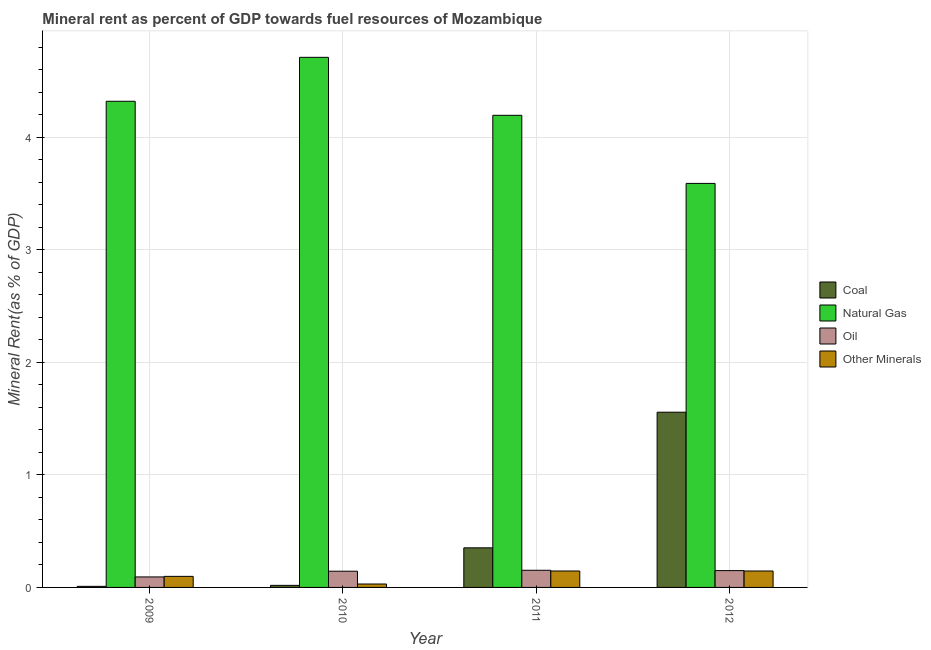Are the number of bars per tick equal to the number of legend labels?
Give a very brief answer. Yes. How many bars are there on the 4th tick from the left?
Ensure brevity in your answer.  4. What is the  rent of other minerals in 2012?
Your answer should be compact. 0.15. Across all years, what is the maximum coal rent?
Ensure brevity in your answer.  1.56. Across all years, what is the minimum coal rent?
Offer a very short reply. 0.01. What is the total coal rent in the graph?
Offer a terse response. 1.94. What is the difference between the coal rent in 2010 and that in 2012?
Offer a very short reply. -1.54. What is the difference between the natural gas rent in 2009 and the oil rent in 2011?
Make the answer very short. 0.12. What is the average oil rent per year?
Your answer should be very brief. 0.13. What is the ratio of the oil rent in 2010 to that in 2011?
Ensure brevity in your answer.  0.95. Is the natural gas rent in 2010 less than that in 2012?
Your answer should be compact. No. Is the difference between the  rent of other minerals in 2010 and 2011 greater than the difference between the natural gas rent in 2010 and 2011?
Provide a succinct answer. No. What is the difference between the highest and the second highest natural gas rent?
Offer a very short reply. 0.39. What is the difference between the highest and the lowest natural gas rent?
Your answer should be very brief. 1.12. In how many years, is the oil rent greater than the average oil rent taken over all years?
Your answer should be very brief. 3. Is it the case that in every year, the sum of the  rent of other minerals and coal rent is greater than the sum of oil rent and natural gas rent?
Give a very brief answer. No. What does the 2nd bar from the left in 2009 represents?
Your answer should be very brief. Natural Gas. What does the 2nd bar from the right in 2012 represents?
Your response must be concise. Oil. How many bars are there?
Your answer should be compact. 16. Are the values on the major ticks of Y-axis written in scientific E-notation?
Your answer should be compact. No. What is the title of the graph?
Ensure brevity in your answer.  Mineral rent as percent of GDP towards fuel resources of Mozambique. Does "Secondary vocational education" appear as one of the legend labels in the graph?
Your answer should be very brief. No. What is the label or title of the X-axis?
Your answer should be compact. Year. What is the label or title of the Y-axis?
Your answer should be very brief. Mineral Rent(as % of GDP). What is the Mineral Rent(as % of GDP) of Coal in 2009?
Provide a short and direct response. 0.01. What is the Mineral Rent(as % of GDP) of Natural Gas in 2009?
Give a very brief answer. 4.32. What is the Mineral Rent(as % of GDP) in Oil in 2009?
Provide a succinct answer. 0.09. What is the Mineral Rent(as % of GDP) in Other Minerals in 2009?
Offer a terse response. 0.1. What is the Mineral Rent(as % of GDP) in Coal in 2010?
Keep it short and to the point. 0.02. What is the Mineral Rent(as % of GDP) in Natural Gas in 2010?
Offer a very short reply. 4.71. What is the Mineral Rent(as % of GDP) of Oil in 2010?
Ensure brevity in your answer.  0.14. What is the Mineral Rent(as % of GDP) in Other Minerals in 2010?
Offer a terse response. 0.03. What is the Mineral Rent(as % of GDP) of Coal in 2011?
Your response must be concise. 0.35. What is the Mineral Rent(as % of GDP) of Natural Gas in 2011?
Make the answer very short. 4.2. What is the Mineral Rent(as % of GDP) in Oil in 2011?
Offer a very short reply. 0.15. What is the Mineral Rent(as % of GDP) in Other Minerals in 2011?
Give a very brief answer. 0.15. What is the Mineral Rent(as % of GDP) of Coal in 2012?
Provide a short and direct response. 1.56. What is the Mineral Rent(as % of GDP) of Natural Gas in 2012?
Provide a short and direct response. 3.59. What is the Mineral Rent(as % of GDP) of Oil in 2012?
Keep it short and to the point. 0.15. What is the Mineral Rent(as % of GDP) in Other Minerals in 2012?
Offer a very short reply. 0.15. Across all years, what is the maximum Mineral Rent(as % of GDP) in Coal?
Make the answer very short. 1.56. Across all years, what is the maximum Mineral Rent(as % of GDP) in Natural Gas?
Give a very brief answer. 4.71. Across all years, what is the maximum Mineral Rent(as % of GDP) in Oil?
Your answer should be compact. 0.15. Across all years, what is the maximum Mineral Rent(as % of GDP) in Other Minerals?
Offer a terse response. 0.15. Across all years, what is the minimum Mineral Rent(as % of GDP) in Coal?
Offer a terse response. 0.01. Across all years, what is the minimum Mineral Rent(as % of GDP) in Natural Gas?
Your answer should be very brief. 3.59. Across all years, what is the minimum Mineral Rent(as % of GDP) of Oil?
Offer a very short reply. 0.09. Across all years, what is the minimum Mineral Rent(as % of GDP) of Other Minerals?
Ensure brevity in your answer.  0.03. What is the total Mineral Rent(as % of GDP) in Coal in the graph?
Keep it short and to the point. 1.94. What is the total Mineral Rent(as % of GDP) in Natural Gas in the graph?
Your answer should be very brief. 16.82. What is the total Mineral Rent(as % of GDP) in Oil in the graph?
Your answer should be very brief. 0.54. What is the total Mineral Rent(as % of GDP) in Other Minerals in the graph?
Ensure brevity in your answer.  0.42. What is the difference between the Mineral Rent(as % of GDP) in Coal in 2009 and that in 2010?
Ensure brevity in your answer.  -0.01. What is the difference between the Mineral Rent(as % of GDP) of Natural Gas in 2009 and that in 2010?
Provide a short and direct response. -0.39. What is the difference between the Mineral Rent(as % of GDP) of Oil in 2009 and that in 2010?
Your answer should be compact. -0.05. What is the difference between the Mineral Rent(as % of GDP) in Other Minerals in 2009 and that in 2010?
Make the answer very short. 0.07. What is the difference between the Mineral Rent(as % of GDP) of Coal in 2009 and that in 2011?
Your response must be concise. -0.34. What is the difference between the Mineral Rent(as % of GDP) in Natural Gas in 2009 and that in 2011?
Ensure brevity in your answer.  0.12. What is the difference between the Mineral Rent(as % of GDP) in Oil in 2009 and that in 2011?
Your response must be concise. -0.06. What is the difference between the Mineral Rent(as % of GDP) in Other Minerals in 2009 and that in 2011?
Your answer should be compact. -0.05. What is the difference between the Mineral Rent(as % of GDP) in Coal in 2009 and that in 2012?
Your answer should be very brief. -1.55. What is the difference between the Mineral Rent(as % of GDP) of Natural Gas in 2009 and that in 2012?
Provide a succinct answer. 0.73. What is the difference between the Mineral Rent(as % of GDP) in Oil in 2009 and that in 2012?
Ensure brevity in your answer.  -0.06. What is the difference between the Mineral Rent(as % of GDP) in Other Minerals in 2009 and that in 2012?
Your answer should be compact. -0.05. What is the difference between the Mineral Rent(as % of GDP) of Coal in 2010 and that in 2011?
Provide a short and direct response. -0.33. What is the difference between the Mineral Rent(as % of GDP) of Natural Gas in 2010 and that in 2011?
Give a very brief answer. 0.52. What is the difference between the Mineral Rent(as % of GDP) of Oil in 2010 and that in 2011?
Your answer should be very brief. -0.01. What is the difference between the Mineral Rent(as % of GDP) in Other Minerals in 2010 and that in 2011?
Your response must be concise. -0.12. What is the difference between the Mineral Rent(as % of GDP) in Coal in 2010 and that in 2012?
Make the answer very short. -1.54. What is the difference between the Mineral Rent(as % of GDP) of Natural Gas in 2010 and that in 2012?
Your answer should be very brief. 1.12. What is the difference between the Mineral Rent(as % of GDP) of Oil in 2010 and that in 2012?
Give a very brief answer. -0.01. What is the difference between the Mineral Rent(as % of GDP) in Other Minerals in 2010 and that in 2012?
Keep it short and to the point. -0.12. What is the difference between the Mineral Rent(as % of GDP) of Coal in 2011 and that in 2012?
Make the answer very short. -1.21. What is the difference between the Mineral Rent(as % of GDP) in Natural Gas in 2011 and that in 2012?
Your answer should be very brief. 0.61. What is the difference between the Mineral Rent(as % of GDP) in Oil in 2011 and that in 2012?
Keep it short and to the point. 0. What is the difference between the Mineral Rent(as % of GDP) in Coal in 2009 and the Mineral Rent(as % of GDP) in Natural Gas in 2010?
Your answer should be compact. -4.7. What is the difference between the Mineral Rent(as % of GDP) in Coal in 2009 and the Mineral Rent(as % of GDP) in Oil in 2010?
Offer a terse response. -0.13. What is the difference between the Mineral Rent(as % of GDP) of Coal in 2009 and the Mineral Rent(as % of GDP) of Other Minerals in 2010?
Offer a very short reply. -0.02. What is the difference between the Mineral Rent(as % of GDP) in Natural Gas in 2009 and the Mineral Rent(as % of GDP) in Oil in 2010?
Your response must be concise. 4.18. What is the difference between the Mineral Rent(as % of GDP) in Natural Gas in 2009 and the Mineral Rent(as % of GDP) in Other Minerals in 2010?
Your answer should be compact. 4.29. What is the difference between the Mineral Rent(as % of GDP) in Oil in 2009 and the Mineral Rent(as % of GDP) in Other Minerals in 2010?
Your answer should be compact. 0.06. What is the difference between the Mineral Rent(as % of GDP) of Coal in 2009 and the Mineral Rent(as % of GDP) of Natural Gas in 2011?
Provide a succinct answer. -4.19. What is the difference between the Mineral Rent(as % of GDP) of Coal in 2009 and the Mineral Rent(as % of GDP) of Oil in 2011?
Your answer should be compact. -0.14. What is the difference between the Mineral Rent(as % of GDP) in Coal in 2009 and the Mineral Rent(as % of GDP) in Other Minerals in 2011?
Give a very brief answer. -0.14. What is the difference between the Mineral Rent(as % of GDP) in Natural Gas in 2009 and the Mineral Rent(as % of GDP) in Oil in 2011?
Provide a succinct answer. 4.17. What is the difference between the Mineral Rent(as % of GDP) of Natural Gas in 2009 and the Mineral Rent(as % of GDP) of Other Minerals in 2011?
Make the answer very short. 4.17. What is the difference between the Mineral Rent(as % of GDP) of Oil in 2009 and the Mineral Rent(as % of GDP) of Other Minerals in 2011?
Offer a very short reply. -0.05. What is the difference between the Mineral Rent(as % of GDP) in Coal in 2009 and the Mineral Rent(as % of GDP) in Natural Gas in 2012?
Your answer should be very brief. -3.58. What is the difference between the Mineral Rent(as % of GDP) in Coal in 2009 and the Mineral Rent(as % of GDP) in Oil in 2012?
Keep it short and to the point. -0.14. What is the difference between the Mineral Rent(as % of GDP) in Coal in 2009 and the Mineral Rent(as % of GDP) in Other Minerals in 2012?
Your answer should be compact. -0.14. What is the difference between the Mineral Rent(as % of GDP) in Natural Gas in 2009 and the Mineral Rent(as % of GDP) in Oil in 2012?
Provide a succinct answer. 4.17. What is the difference between the Mineral Rent(as % of GDP) in Natural Gas in 2009 and the Mineral Rent(as % of GDP) in Other Minerals in 2012?
Your answer should be compact. 4.17. What is the difference between the Mineral Rent(as % of GDP) of Oil in 2009 and the Mineral Rent(as % of GDP) of Other Minerals in 2012?
Offer a very short reply. -0.05. What is the difference between the Mineral Rent(as % of GDP) in Coal in 2010 and the Mineral Rent(as % of GDP) in Natural Gas in 2011?
Make the answer very short. -4.18. What is the difference between the Mineral Rent(as % of GDP) in Coal in 2010 and the Mineral Rent(as % of GDP) in Oil in 2011?
Give a very brief answer. -0.13. What is the difference between the Mineral Rent(as % of GDP) in Coal in 2010 and the Mineral Rent(as % of GDP) in Other Minerals in 2011?
Provide a succinct answer. -0.13. What is the difference between the Mineral Rent(as % of GDP) in Natural Gas in 2010 and the Mineral Rent(as % of GDP) in Oil in 2011?
Give a very brief answer. 4.56. What is the difference between the Mineral Rent(as % of GDP) in Natural Gas in 2010 and the Mineral Rent(as % of GDP) in Other Minerals in 2011?
Offer a very short reply. 4.56. What is the difference between the Mineral Rent(as % of GDP) of Oil in 2010 and the Mineral Rent(as % of GDP) of Other Minerals in 2011?
Ensure brevity in your answer.  -0. What is the difference between the Mineral Rent(as % of GDP) of Coal in 2010 and the Mineral Rent(as % of GDP) of Natural Gas in 2012?
Provide a short and direct response. -3.57. What is the difference between the Mineral Rent(as % of GDP) of Coal in 2010 and the Mineral Rent(as % of GDP) of Oil in 2012?
Make the answer very short. -0.13. What is the difference between the Mineral Rent(as % of GDP) of Coal in 2010 and the Mineral Rent(as % of GDP) of Other Minerals in 2012?
Your answer should be compact. -0.13. What is the difference between the Mineral Rent(as % of GDP) of Natural Gas in 2010 and the Mineral Rent(as % of GDP) of Oil in 2012?
Offer a very short reply. 4.56. What is the difference between the Mineral Rent(as % of GDP) in Natural Gas in 2010 and the Mineral Rent(as % of GDP) in Other Minerals in 2012?
Offer a very short reply. 4.56. What is the difference between the Mineral Rent(as % of GDP) in Oil in 2010 and the Mineral Rent(as % of GDP) in Other Minerals in 2012?
Your response must be concise. -0. What is the difference between the Mineral Rent(as % of GDP) of Coal in 2011 and the Mineral Rent(as % of GDP) of Natural Gas in 2012?
Make the answer very short. -3.24. What is the difference between the Mineral Rent(as % of GDP) of Coal in 2011 and the Mineral Rent(as % of GDP) of Oil in 2012?
Provide a succinct answer. 0.2. What is the difference between the Mineral Rent(as % of GDP) of Coal in 2011 and the Mineral Rent(as % of GDP) of Other Minerals in 2012?
Keep it short and to the point. 0.21. What is the difference between the Mineral Rent(as % of GDP) of Natural Gas in 2011 and the Mineral Rent(as % of GDP) of Oil in 2012?
Provide a short and direct response. 4.05. What is the difference between the Mineral Rent(as % of GDP) of Natural Gas in 2011 and the Mineral Rent(as % of GDP) of Other Minerals in 2012?
Provide a short and direct response. 4.05. What is the difference between the Mineral Rent(as % of GDP) in Oil in 2011 and the Mineral Rent(as % of GDP) in Other Minerals in 2012?
Offer a terse response. 0.01. What is the average Mineral Rent(as % of GDP) of Coal per year?
Ensure brevity in your answer.  0.48. What is the average Mineral Rent(as % of GDP) of Natural Gas per year?
Offer a very short reply. 4.2. What is the average Mineral Rent(as % of GDP) in Oil per year?
Provide a succinct answer. 0.13. What is the average Mineral Rent(as % of GDP) of Other Minerals per year?
Provide a short and direct response. 0.11. In the year 2009, what is the difference between the Mineral Rent(as % of GDP) in Coal and Mineral Rent(as % of GDP) in Natural Gas?
Offer a very short reply. -4.31. In the year 2009, what is the difference between the Mineral Rent(as % of GDP) of Coal and Mineral Rent(as % of GDP) of Oil?
Provide a succinct answer. -0.08. In the year 2009, what is the difference between the Mineral Rent(as % of GDP) in Coal and Mineral Rent(as % of GDP) in Other Minerals?
Offer a terse response. -0.09. In the year 2009, what is the difference between the Mineral Rent(as % of GDP) of Natural Gas and Mineral Rent(as % of GDP) of Oil?
Ensure brevity in your answer.  4.23. In the year 2009, what is the difference between the Mineral Rent(as % of GDP) in Natural Gas and Mineral Rent(as % of GDP) in Other Minerals?
Give a very brief answer. 4.22. In the year 2009, what is the difference between the Mineral Rent(as % of GDP) of Oil and Mineral Rent(as % of GDP) of Other Minerals?
Make the answer very short. -0.01. In the year 2010, what is the difference between the Mineral Rent(as % of GDP) in Coal and Mineral Rent(as % of GDP) in Natural Gas?
Your answer should be compact. -4.69. In the year 2010, what is the difference between the Mineral Rent(as % of GDP) of Coal and Mineral Rent(as % of GDP) of Oil?
Your response must be concise. -0.13. In the year 2010, what is the difference between the Mineral Rent(as % of GDP) of Coal and Mineral Rent(as % of GDP) of Other Minerals?
Give a very brief answer. -0.01. In the year 2010, what is the difference between the Mineral Rent(as % of GDP) of Natural Gas and Mineral Rent(as % of GDP) of Oil?
Your answer should be very brief. 4.57. In the year 2010, what is the difference between the Mineral Rent(as % of GDP) of Natural Gas and Mineral Rent(as % of GDP) of Other Minerals?
Provide a short and direct response. 4.68. In the year 2010, what is the difference between the Mineral Rent(as % of GDP) of Oil and Mineral Rent(as % of GDP) of Other Minerals?
Keep it short and to the point. 0.11. In the year 2011, what is the difference between the Mineral Rent(as % of GDP) of Coal and Mineral Rent(as % of GDP) of Natural Gas?
Make the answer very short. -3.84. In the year 2011, what is the difference between the Mineral Rent(as % of GDP) of Coal and Mineral Rent(as % of GDP) of Oil?
Provide a short and direct response. 0.2. In the year 2011, what is the difference between the Mineral Rent(as % of GDP) of Coal and Mineral Rent(as % of GDP) of Other Minerals?
Provide a short and direct response. 0.21. In the year 2011, what is the difference between the Mineral Rent(as % of GDP) in Natural Gas and Mineral Rent(as % of GDP) in Oil?
Give a very brief answer. 4.04. In the year 2011, what is the difference between the Mineral Rent(as % of GDP) of Natural Gas and Mineral Rent(as % of GDP) of Other Minerals?
Keep it short and to the point. 4.05. In the year 2011, what is the difference between the Mineral Rent(as % of GDP) in Oil and Mineral Rent(as % of GDP) in Other Minerals?
Provide a succinct answer. 0.01. In the year 2012, what is the difference between the Mineral Rent(as % of GDP) of Coal and Mineral Rent(as % of GDP) of Natural Gas?
Keep it short and to the point. -2.03. In the year 2012, what is the difference between the Mineral Rent(as % of GDP) in Coal and Mineral Rent(as % of GDP) in Oil?
Your response must be concise. 1.41. In the year 2012, what is the difference between the Mineral Rent(as % of GDP) in Coal and Mineral Rent(as % of GDP) in Other Minerals?
Give a very brief answer. 1.41. In the year 2012, what is the difference between the Mineral Rent(as % of GDP) of Natural Gas and Mineral Rent(as % of GDP) of Oil?
Give a very brief answer. 3.44. In the year 2012, what is the difference between the Mineral Rent(as % of GDP) in Natural Gas and Mineral Rent(as % of GDP) in Other Minerals?
Provide a succinct answer. 3.44. In the year 2012, what is the difference between the Mineral Rent(as % of GDP) of Oil and Mineral Rent(as % of GDP) of Other Minerals?
Keep it short and to the point. 0. What is the ratio of the Mineral Rent(as % of GDP) in Coal in 2009 to that in 2010?
Your answer should be very brief. 0.52. What is the ratio of the Mineral Rent(as % of GDP) of Natural Gas in 2009 to that in 2010?
Your answer should be very brief. 0.92. What is the ratio of the Mineral Rent(as % of GDP) in Oil in 2009 to that in 2010?
Provide a short and direct response. 0.65. What is the ratio of the Mineral Rent(as % of GDP) in Other Minerals in 2009 to that in 2010?
Give a very brief answer. 3.23. What is the ratio of the Mineral Rent(as % of GDP) in Coal in 2009 to that in 2011?
Your answer should be very brief. 0.03. What is the ratio of the Mineral Rent(as % of GDP) in Natural Gas in 2009 to that in 2011?
Your response must be concise. 1.03. What is the ratio of the Mineral Rent(as % of GDP) of Oil in 2009 to that in 2011?
Keep it short and to the point. 0.61. What is the ratio of the Mineral Rent(as % of GDP) of Other Minerals in 2009 to that in 2011?
Provide a succinct answer. 0.67. What is the ratio of the Mineral Rent(as % of GDP) in Coal in 2009 to that in 2012?
Your answer should be very brief. 0.01. What is the ratio of the Mineral Rent(as % of GDP) in Natural Gas in 2009 to that in 2012?
Offer a terse response. 1.2. What is the ratio of the Mineral Rent(as % of GDP) in Oil in 2009 to that in 2012?
Your response must be concise. 0.62. What is the ratio of the Mineral Rent(as % of GDP) in Other Minerals in 2009 to that in 2012?
Offer a very short reply. 0.67. What is the ratio of the Mineral Rent(as % of GDP) of Coal in 2010 to that in 2011?
Give a very brief answer. 0.05. What is the ratio of the Mineral Rent(as % of GDP) of Natural Gas in 2010 to that in 2011?
Ensure brevity in your answer.  1.12. What is the ratio of the Mineral Rent(as % of GDP) in Oil in 2010 to that in 2011?
Offer a terse response. 0.94. What is the ratio of the Mineral Rent(as % of GDP) in Other Minerals in 2010 to that in 2011?
Keep it short and to the point. 0.21. What is the ratio of the Mineral Rent(as % of GDP) in Coal in 2010 to that in 2012?
Provide a succinct answer. 0.01. What is the ratio of the Mineral Rent(as % of GDP) in Natural Gas in 2010 to that in 2012?
Your response must be concise. 1.31. What is the ratio of the Mineral Rent(as % of GDP) of Oil in 2010 to that in 2012?
Keep it short and to the point. 0.96. What is the ratio of the Mineral Rent(as % of GDP) of Other Minerals in 2010 to that in 2012?
Offer a very short reply. 0.21. What is the ratio of the Mineral Rent(as % of GDP) in Coal in 2011 to that in 2012?
Offer a very short reply. 0.23. What is the ratio of the Mineral Rent(as % of GDP) of Natural Gas in 2011 to that in 2012?
Your answer should be very brief. 1.17. What is the ratio of the Mineral Rent(as % of GDP) of Oil in 2011 to that in 2012?
Your answer should be very brief. 1.02. What is the difference between the highest and the second highest Mineral Rent(as % of GDP) of Coal?
Ensure brevity in your answer.  1.21. What is the difference between the highest and the second highest Mineral Rent(as % of GDP) of Natural Gas?
Offer a terse response. 0.39. What is the difference between the highest and the second highest Mineral Rent(as % of GDP) of Oil?
Give a very brief answer. 0. What is the difference between the highest and the lowest Mineral Rent(as % of GDP) of Coal?
Offer a terse response. 1.55. What is the difference between the highest and the lowest Mineral Rent(as % of GDP) of Natural Gas?
Offer a very short reply. 1.12. What is the difference between the highest and the lowest Mineral Rent(as % of GDP) in Oil?
Provide a succinct answer. 0.06. What is the difference between the highest and the lowest Mineral Rent(as % of GDP) in Other Minerals?
Give a very brief answer. 0.12. 